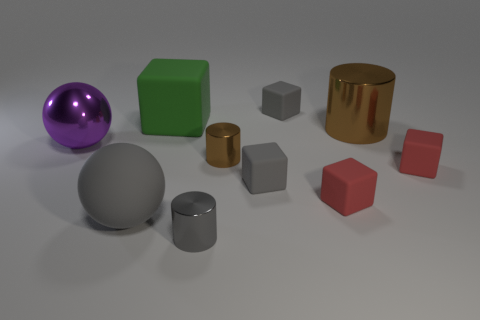What number of tiny red things have the same material as the green block?
Offer a very short reply. 2. There is a big purple metal thing; what number of small metal objects are to the left of it?
Ensure brevity in your answer.  0. How big is the rubber sphere?
Provide a succinct answer. Large. What is the color of the matte ball that is the same size as the green block?
Your response must be concise. Gray. Is there a tiny matte object of the same color as the rubber sphere?
Offer a terse response. Yes. What is the material of the green cube?
Make the answer very short. Rubber. How many big red balls are there?
Your answer should be very brief. 0. There is a big shiny thing that is to the right of the purple metallic object; does it have the same color as the large rubber thing in front of the small brown metal thing?
Provide a succinct answer. No. What is the size of the metallic object that is the same color as the large shiny cylinder?
Your answer should be very brief. Small. What number of other things are the same size as the gray shiny cylinder?
Ensure brevity in your answer.  5. 